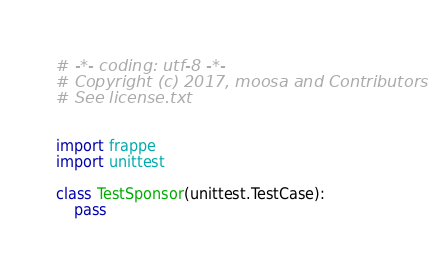<code> <loc_0><loc_0><loc_500><loc_500><_Python_># -*- coding: utf-8 -*-
# Copyright (c) 2017, moosa and Contributors
# See license.txt


import frappe
import unittest

class TestSponsor(unittest.TestCase):
	pass
</code> 